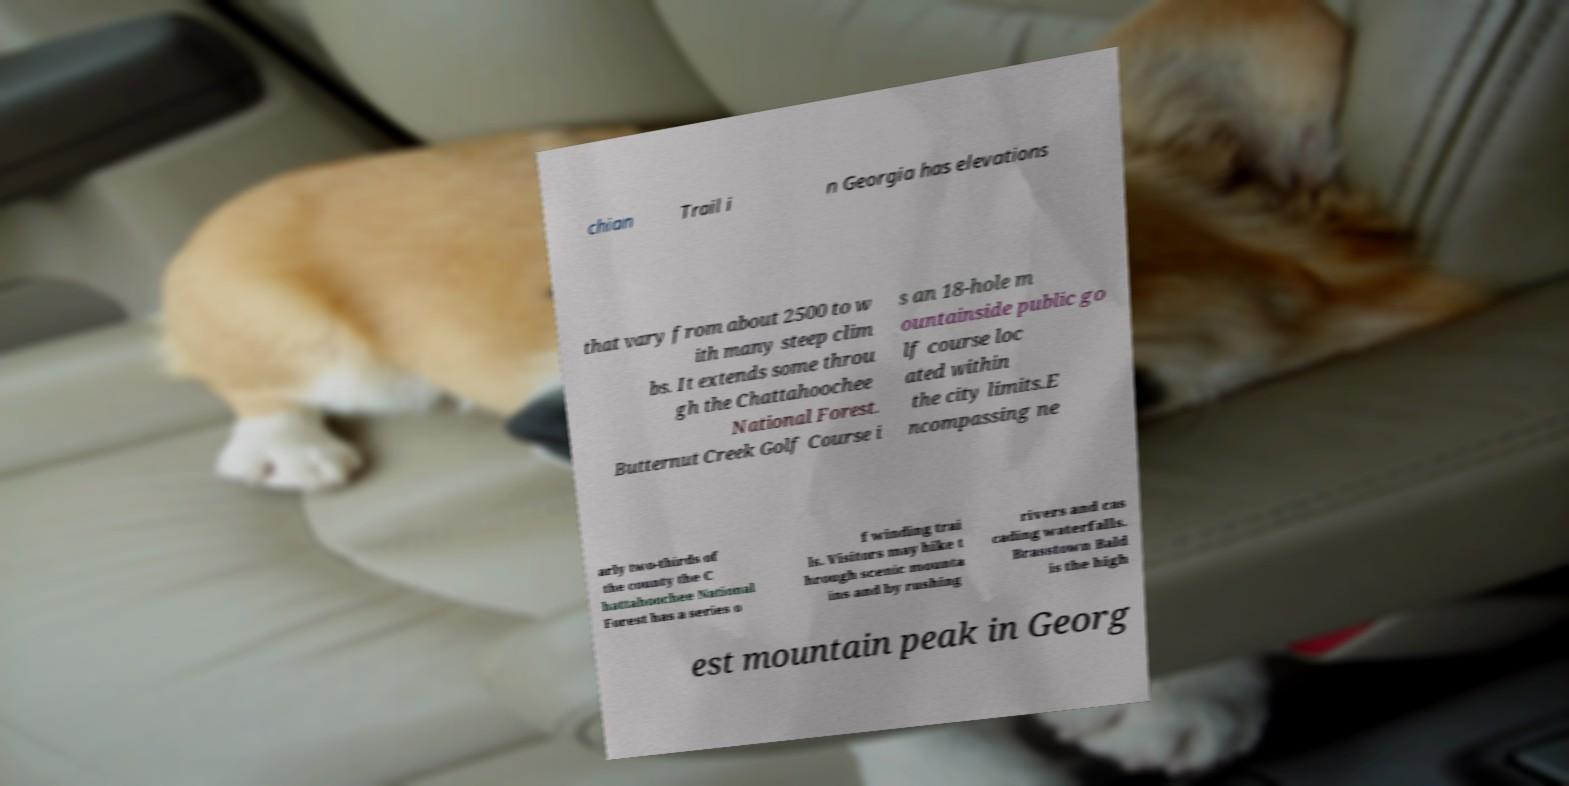What messages or text are displayed in this image? I need them in a readable, typed format. chian Trail i n Georgia has elevations that vary from about 2500 to w ith many steep clim bs. It extends some throu gh the Chattahoochee National Forest. Butternut Creek Golf Course i s an 18-hole m ountainside public go lf course loc ated within the city limits.E ncompassing ne arly two-thirds of the county the C hattahoochee National Forest has a series o f winding trai ls. Visitors may hike t hrough scenic mounta ins and by rushing rivers and cas cading waterfalls. Brasstown Bald is the high est mountain peak in Georg 